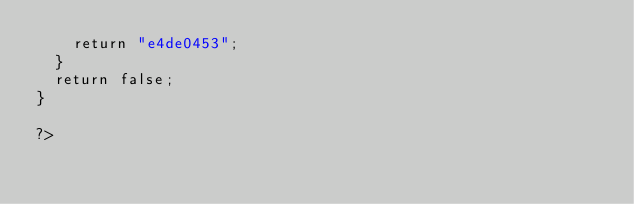<code> <loc_0><loc_0><loc_500><loc_500><_PHP_>		return "e4de0453";
	}
	return false;
}

?>
</code> 